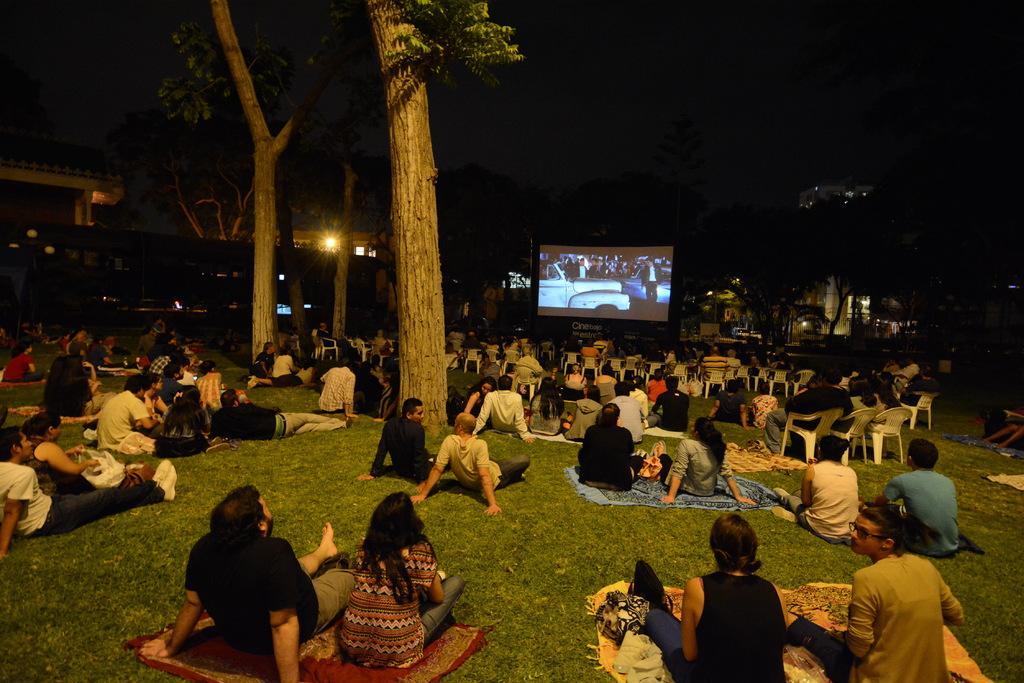Can you describe this image briefly? In this picture we can see some people are sitting on the ground, at the bottom there is grass, there is a screen in the middle, in the background there are some trees and a light, we can also see clothes at the bottom. 